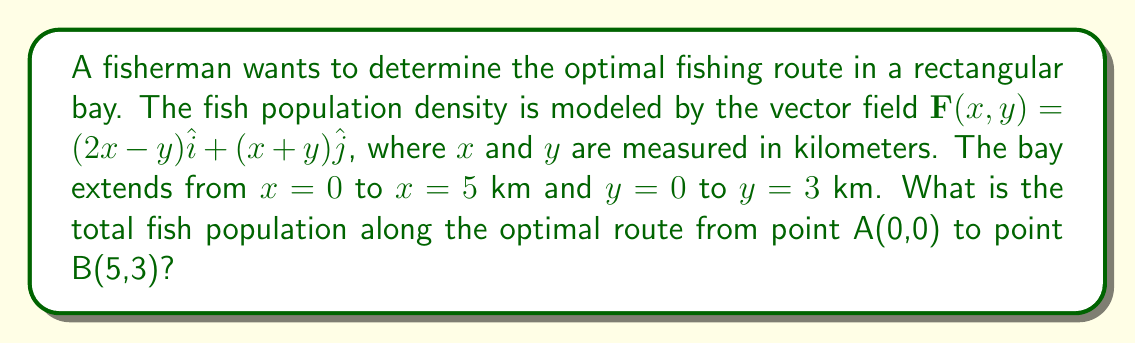Teach me how to tackle this problem. To solve this problem, we'll follow these steps:

1) The optimal fishing route will be the path that maximizes the line integral of the vector field $\mathbf{F}(x,y)$ from point A to point B.

2) For a conservative vector field, the optimal path is always a straight line between two points, regardless of the field. We need to check if $\mathbf{F}(x,y)$ is conservative.

3) To be conservative, $\frac{\partial P}{\partial y} = \frac{\partial Q}{\partial x}$, where $P = 2x-y$ and $Q = x+y$.

   $\frac{\partial P}{\partial y} = -1$ and $\frac{\partial Q}{\partial x} = 1$

   Since these are not equal, $\mathbf{F}(x,y)$ is not conservative.

4) For non-conservative fields, the optimal path follows the gradient of the potential function. However, finding this path analytically can be complex.

5) Given the rectangular shape of the bay, we can approximate the optimal path as the sum of two straight lines: from (0,0) to (5,0), then from (5,0) to (5,3).

6) We'll calculate the line integral along this path:

   $\int_C \mathbf{F} \cdot d\mathbf{r} = \int_0^5 (2x-0)dx + \int_0^3 (5+y)dy$

7) Evaluating the integrals:

   $\int_0^5 (2x)dx + \int_0^3 (5+y)dy = [x^2]_0^5 + [5y + \frac{y^2}{2}]_0^3$

   $= 25 + (15 + \frac{9}{2}) = 25 + 19.5 = 44.5$

Therefore, the total fish population along this approximated optimal route is 44.5 units.
Answer: 44.5 units 